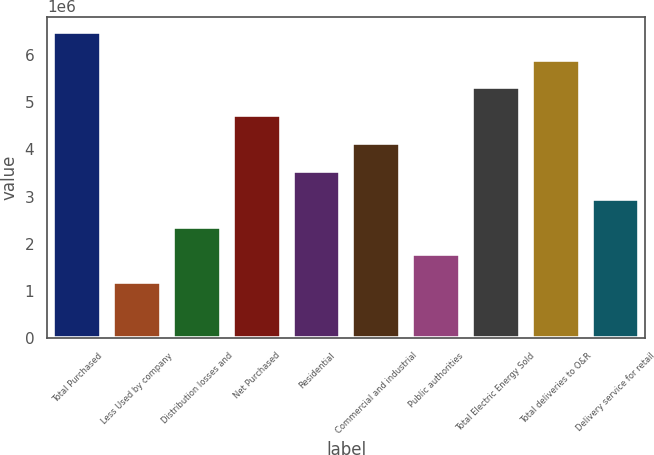Convert chart. <chart><loc_0><loc_0><loc_500><loc_500><bar_chart><fcel>Total Purchased<fcel>Less Used by company<fcel>Distribution losses and<fcel>Net Purchased<fcel>Residential<fcel>Commercial and industrial<fcel>Public authorities<fcel>Total Electric Energy Sold<fcel>Total deliveries to O&R<fcel>Delivery service for retail<nl><fcel>6.4978e+06<fcel>1.18143e+06<fcel>2.36285e+06<fcel>4.72568e+06<fcel>3.54426e+06<fcel>4.13497e+06<fcel>1.77214e+06<fcel>5.31639e+06<fcel>5.9071e+06<fcel>2.95356e+06<nl></chart> 